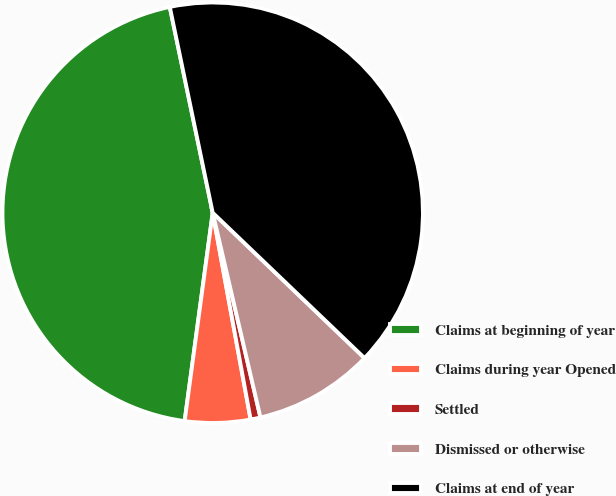Convert chart. <chart><loc_0><loc_0><loc_500><loc_500><pie_chart><fcel>Claims at beginning of year<fcel>Claims during year Opened<fcel>Settled<fcel>Dismissed or otherwise<fcel>Claims at end of year<nl><fcel>44.6%<fcel>5.02%<fcel>0.76%<fcel>9.2%<fcel>40.43%<nl></chart> 